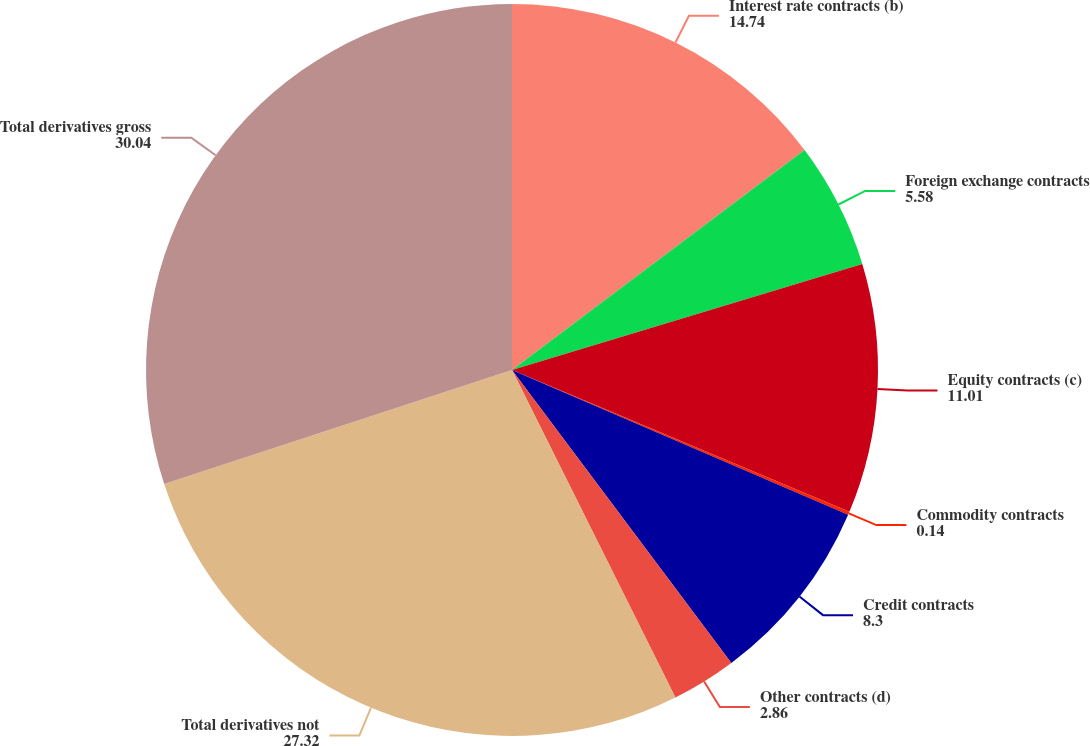Convert chart to OTSL. <chart><loc_0><loc_0><loc_500><loc_500><pie_chart><fcel>Interest rate contracts (b)<fcel>Foreign exchange contracts<fcel>Equity contracts (c)<fcel>Commodity contracts<fcel>Credit contracts<fcel>Other contracts (d)<fcel>Total derivatives not<fcel>Total derivatives gross<nl><fcel>14.74%<fcel>5.58%<fcel>11.01%<fcel>0.14%<fcel>8.3%<fcel>2.86%<fcel>27.32%<fcel>30.04%<nl></chart> 